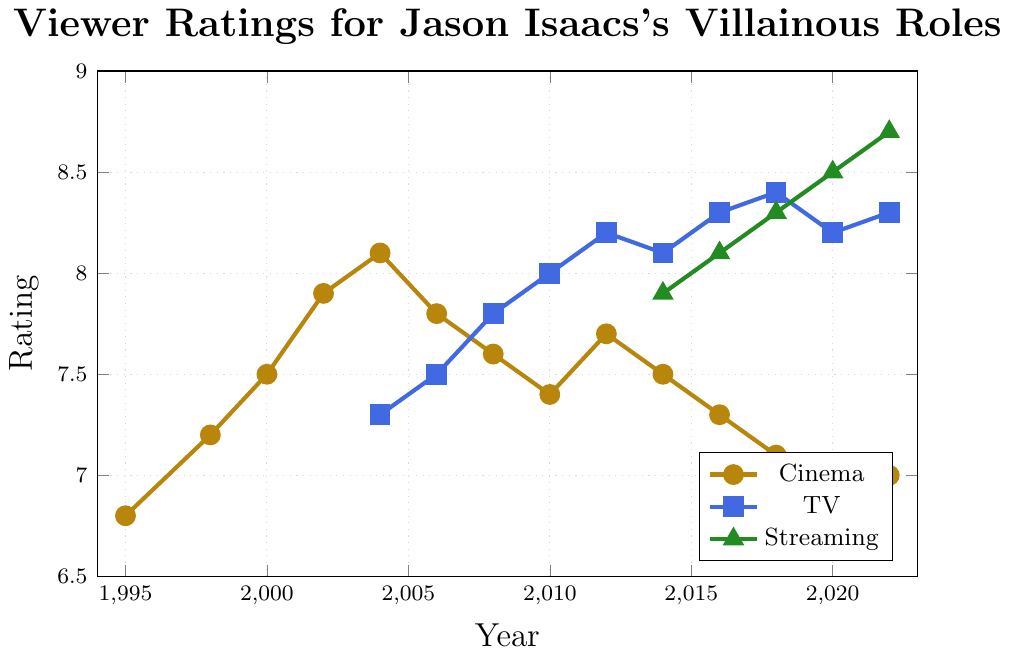What's the overall trend in cinema viewer ratings for Jason Isaacs's villainous roles from 1995 to 2022? The cinema viewer ratings start at 6.8 in 1995, generally increase to a peak of 8.1 in 2004, then show a gradual decline to 7.0 by 2022.
Answer: Increasing then decreasing Which platform had the highest viewer rating in 2022? In 2022, the ratings are 7.0 for cinema, 8.3 for TV, and 8.7 for streaming. The highest rating among these is for streaming.
Answer: Streaming What was the difference in TV viewer ratings between 2004 and 2018? In 2004, the TV viewer rating is 7.3, and in 2018 it is 8.4. The difference is 8.4 - 7.3.
Answer: 1.1 Compare the viewer ratings for TV and Cinema in 2016. Which one had a higher rating and by how much? In 2016, the TV rating is 8.3 and the Cinema rating is 7.3. TV rating is higher, and the difference is 8.3 - 7.3.
Answer: TV by 1.0 Which year had the highest cinema viewer rating, and what was the rating? The highest cinema viewer rating is in 2004 with a rating of 8.1.
Answer: 2004, 8.1 How many years did streaming ratings increase consecutively from 2014 to 2022? The streaming ratings from 2014 to 2022 are: 7.9, 8.1, 8.3, 8.5, 8.7. Each year shows an increase over the previous year.
Answer: 4 years What is the average TV viewer rating from 2016 to 2022? The TV viewer ratings from 2016 to 2022 are: 8.3, 8.4, 8.2, 8.3. The sum is 8.3 + 8.4 + 8.2 + 8.3 = 33.2. The average is 33.2 / 4.
Answer: 8.3 Identify a period where Cinema ratings consistently decreased. From 2004 to 2018, the cinema ratings generally decrease: 8.1 (2004), 7.8 (2006), 7.6 (2008), 7.4 (2010), 7.7 (2012), 7.5 (2014), 7.3 (2016), 7.1 (2018), indicating a period of consistent decline.
Answer: 2004-2018 What was the difference between the highest and lowest streaming ratings? The highest streaming rating is 8.7 (2022) and the lowest is 7.9 (2014). The difference is 8.7 - 7.9.
Answer: 0.8 How do the viewer ratings for Jason Isaacs's roles on Streaming compare to those on TV from 2014 to 2022? From 2014 to 2022, streaming ratings are: 7.9, 8.1, 8.3, 8.5, 8.7. TV ratings are: 8.1, 8.3, 8.4, 8.2, 8.3. Generally, streaming ratings are slightly higher in recent years, especially from 2018 onwards.
Answer: Higher in recent years 